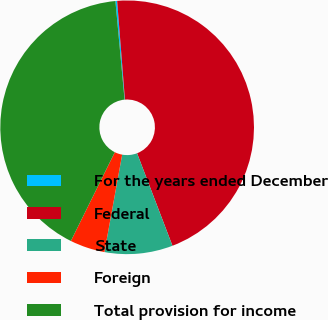<chart> <loc_0><loc_0><loc_500><loc_500><pie_chart><fcel>For the years ended December<fcel>Federal<fcel>State<fcel>Foreign<fcel>Total provision for income<nl><fcel>0.22%<fcel>45.44%<fcel>8.68%<fcel>4.45%<fcel>41.21%<nl></chart> 